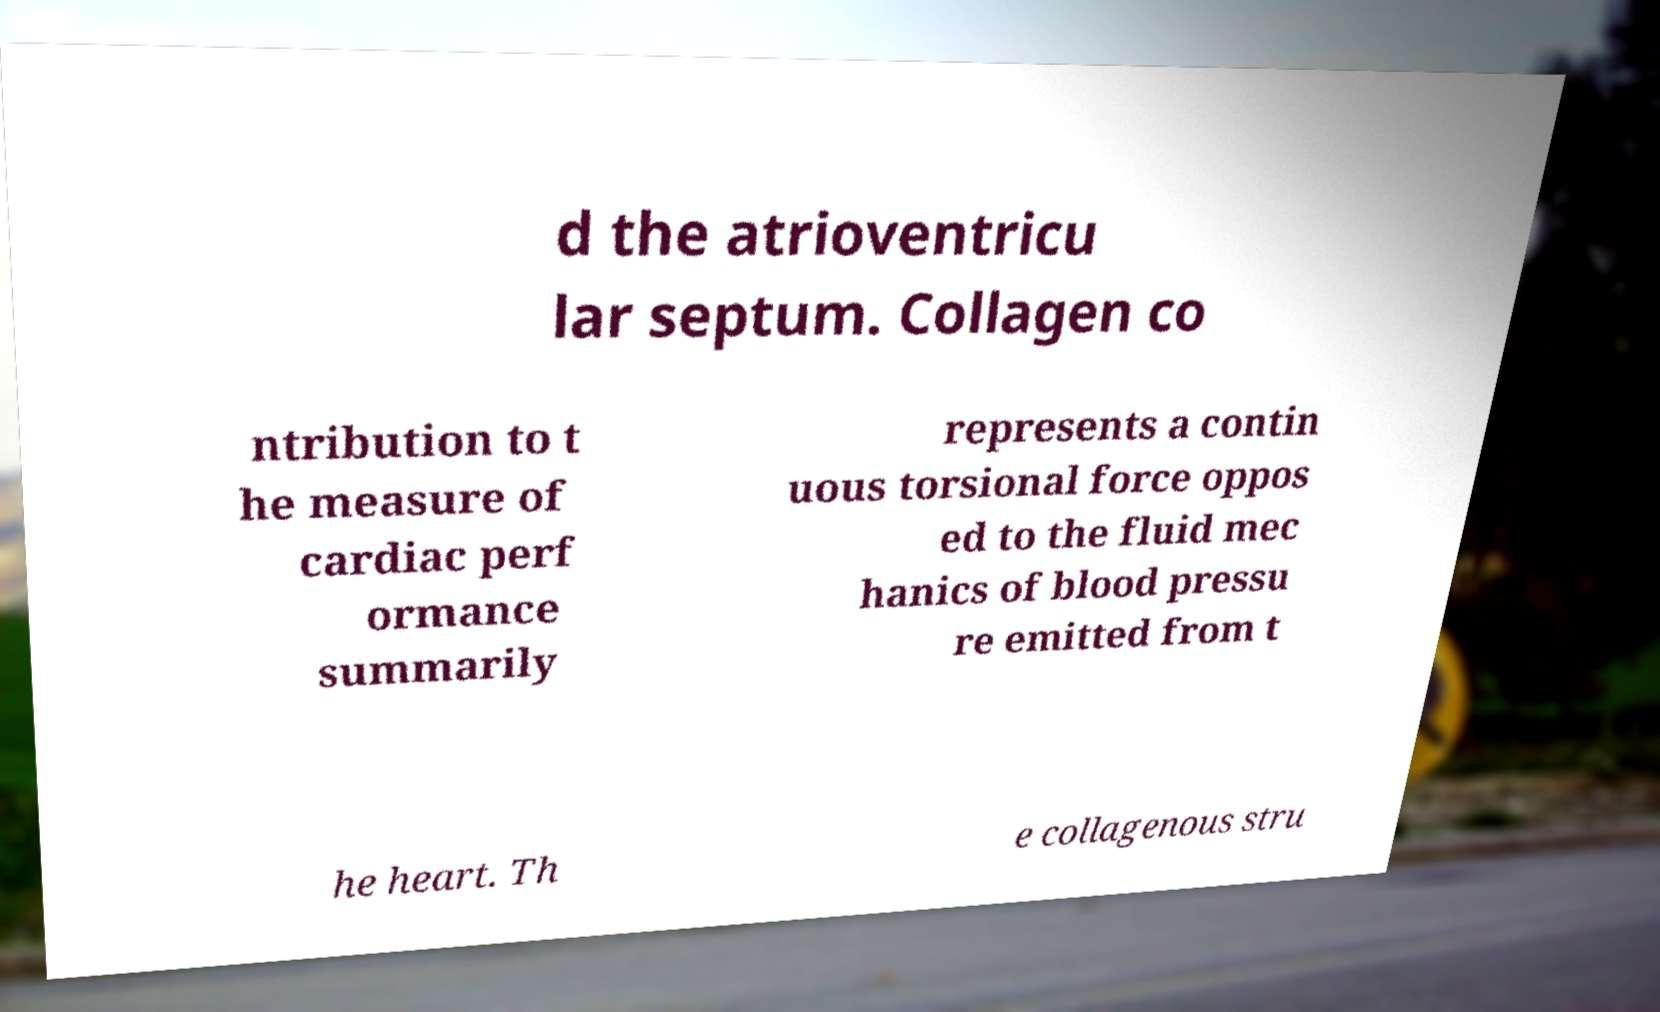Please identify and transcribe the text found in this image. d the atrioventricu lar septum. Collagen co ntribution to t he measure of cardiac perf ormance summarily represents a contin uous torsional force oppos ed to the fluid mec hanics of blood pressu re emitted from t he heart. Th e collagenous stru 